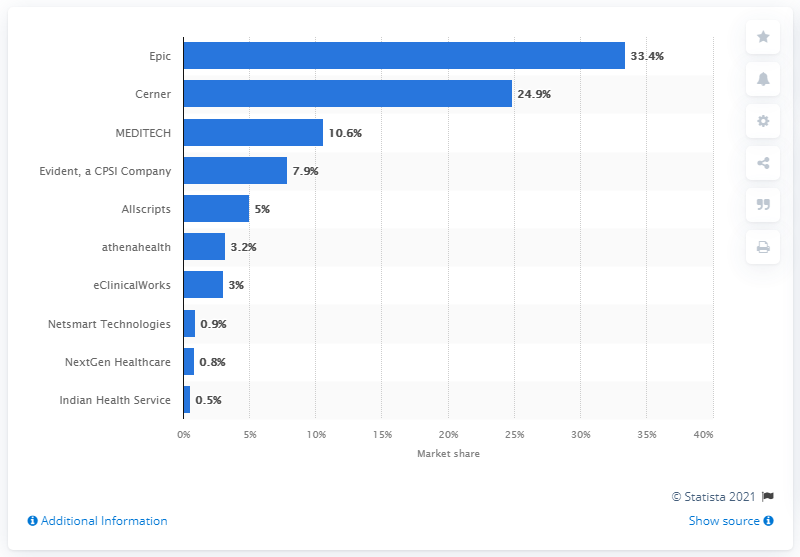List a handful of essential elements in this visual. In 2019, Epic was the leading ambulatory electronic health record (EHR) vendor in the United States. 